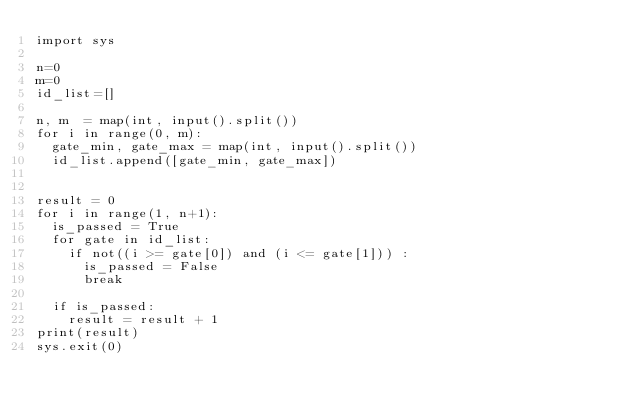Convert code to text. <code><loc_0><loc_0><loc_500><loc_500><_Python_>import sys
 
n=0
m=0
id_list=[]

n, m  = map(int, input().split())
for i in range(0, m):
  gate_min, gate_max = map(int, input().split())
  id_list.append([gate_min, gate_max])
 

result = 0
for i in range(1, n+1):
  is_passed = True
  for gate in id_list:
    if not((i >= gate[0]) and (i <= gate[1])) :
      is_passed = False
      break

  if is_passed:
    result = result + 1	
print(result)
sys.exit(0)</code> 